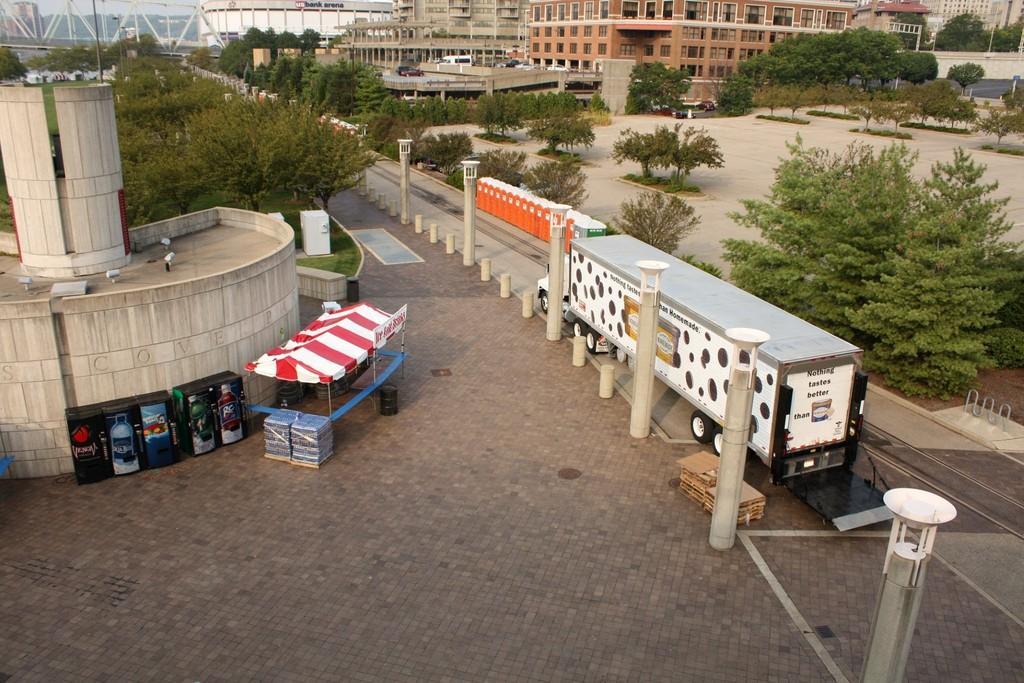Describe this image in one or two sentences. In this image there is a vehicle moving on the road and there is a tent which is red in colour. There are black colour objects. In the background there are trees, building, poles. 